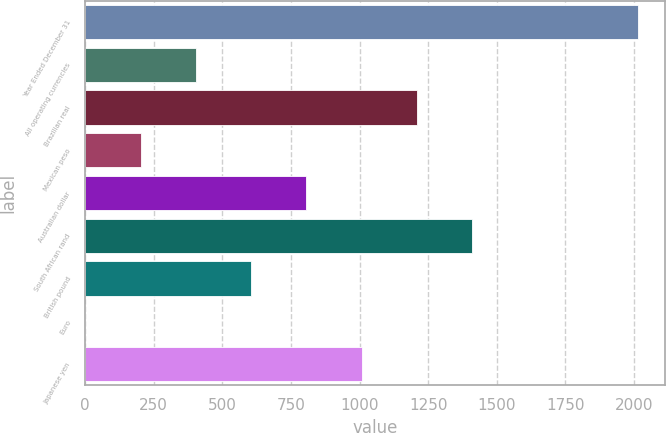<chart> <loc_0><loc_0><loc_500><loc_500><bar_chart><fcel>Year Ended December 31<fcel>All operating currencies<fcel>Brazilian real<fcel>Mexican peso<fcel>Australian dollar<fcel>South African rand<fcel>British pound<fcel>Euro<fcel>Japanese yen<nl><fcel>2014<fcel>403.6<fcel>1208.8<fcel>202.3<fcel>806.2<fcel>1410.1<fcel>604.9<fcel>1<fcel>1007.5<nl></chart> 